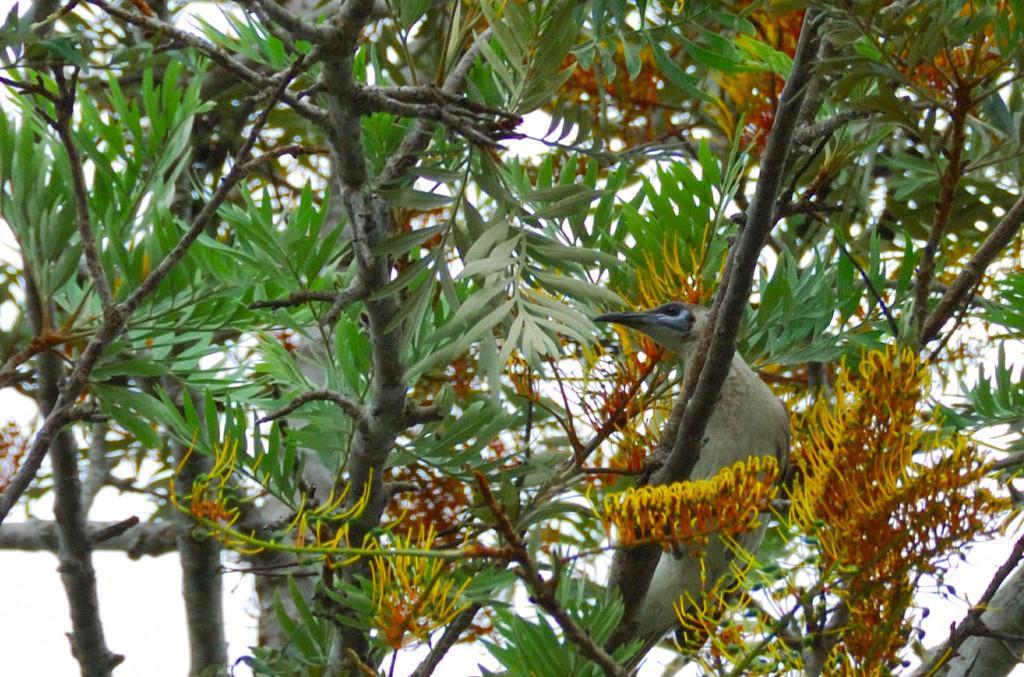In one or two sentences, can you explain what this image depicts? This picture is clicked outside. On the right we can see a bird like thing seems to be standing on the branch of a tree and we can see the leaves and some other objects. In the background we can see the sky. 